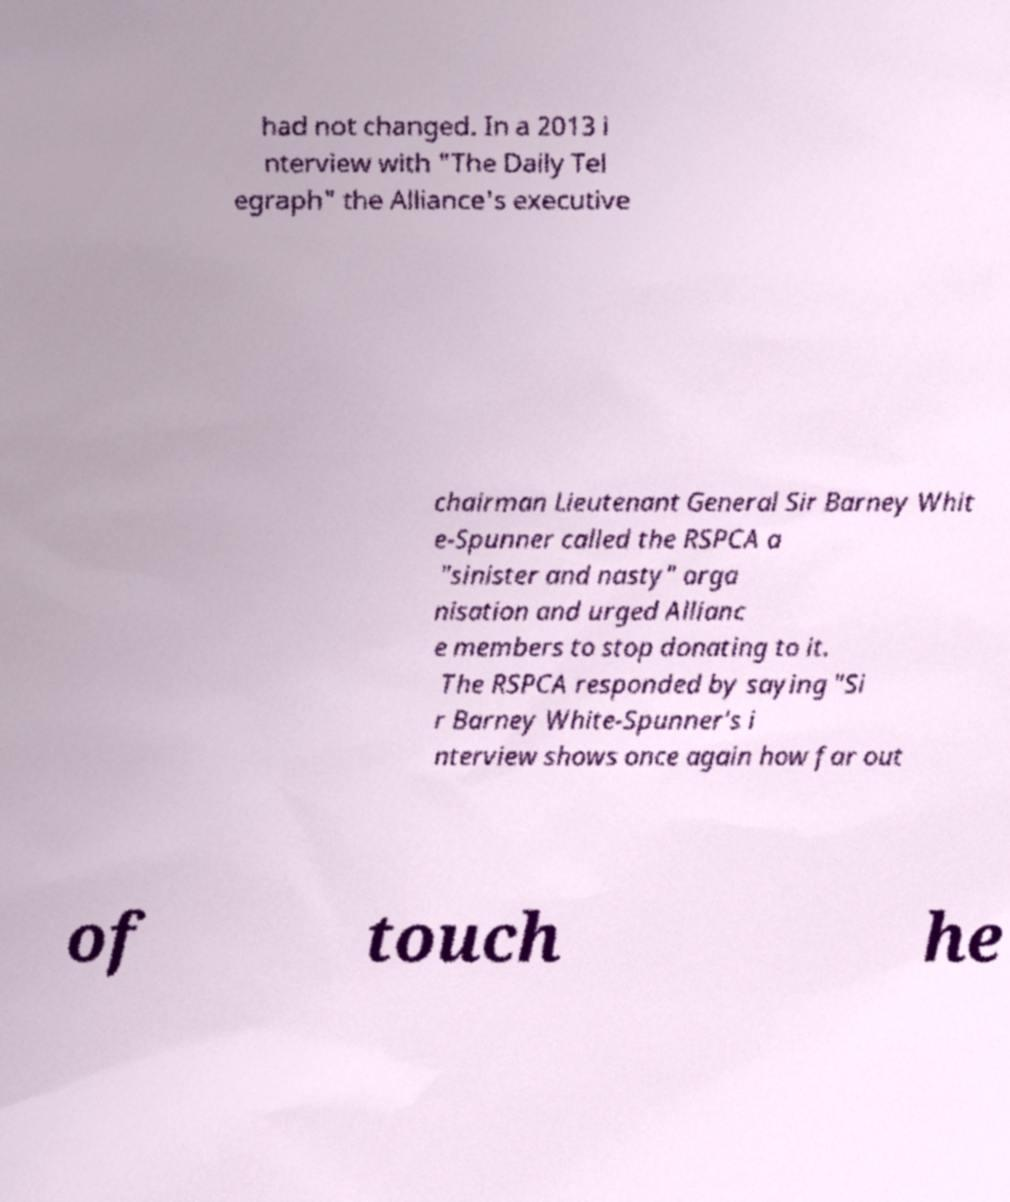Please read and relay the text visible in this image. What does it say? had not changed. In a 2013 i nterview with "The Daily Tel egraph" the Alliance's executive chairman Lieutenant General Sir Barney Whit e-Spunner called the RSPCA a "sinister and nasty" orga nisation and urged Allianc e members to stop donating to it. The RSPCA responded by saying "Si r Barney White-Spunner's i nterview shows once again how far out of touch he 